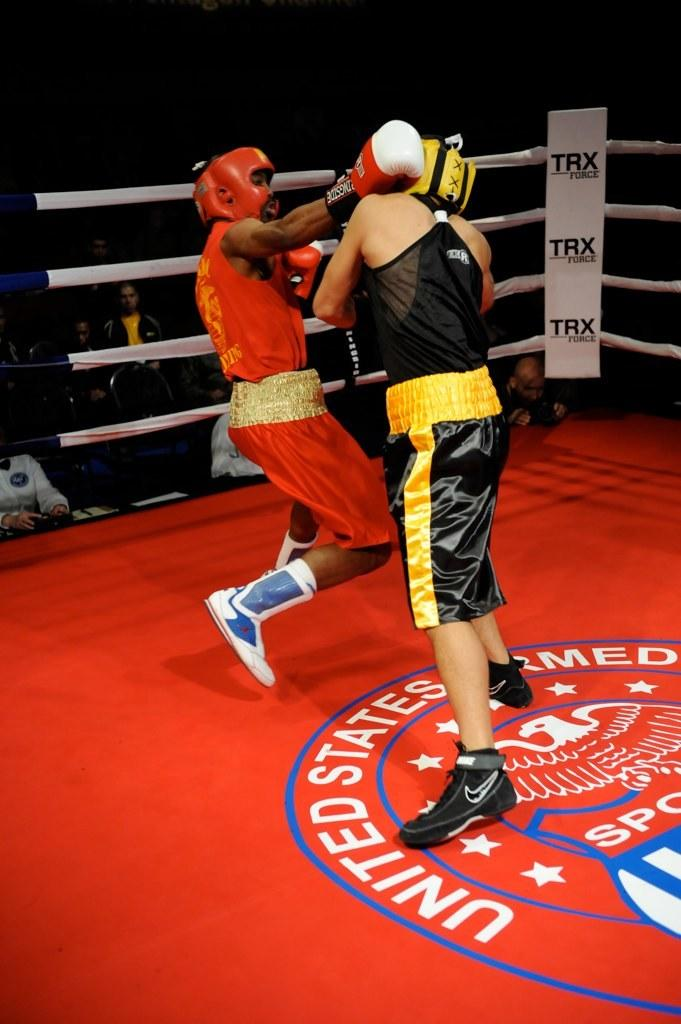<image>
Share a concise interpretation of the image provided. two boxers going at it in red ring that has united states armed forces sports emblem 